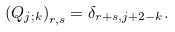<formula> <loc_0><loc_0><loc_500><loc_500>\left ( Q _ { j ; k } \right ) _ { r , s } = \delta _ { r + s , j + 2 - k } .</formula> 